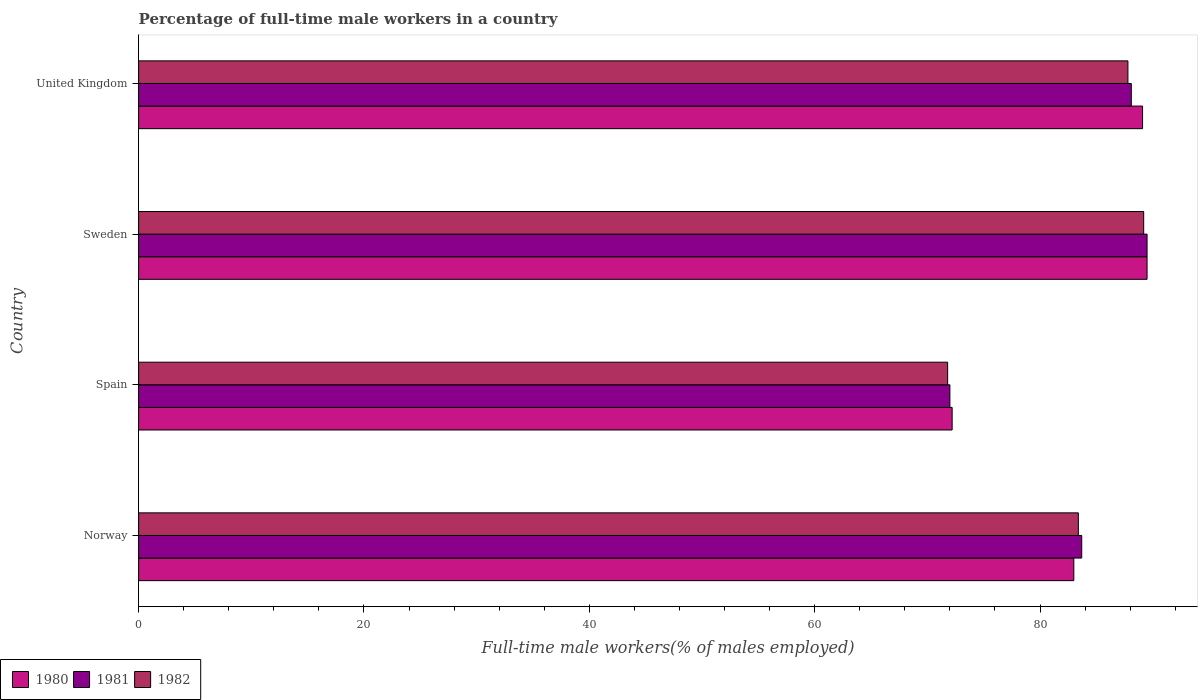How many different coloured bars are there?
Offer a terse response. 3. Are the number of bars per tick equal to the number of legend labels?
Your answer should be very brief. Yes. Are the number of bars on each tick of the Y-axis equal?
Your answer should be very brief. Yes. How many bars are there on the 1st tick from the bottom?
Keep it short and to the point. 3. What is the percentage of full-time male workers in 1982 in Sweden?
Make the answer very short. 89.2. Across all countries, what is the maximum percentage of full-time male workers in 1982?
Keep it short and to the point. 89.2. Across all countries, what is the minimum percentage of full-time male workers in 1981?
Your response must be concise. 72. In which country was the percentage of full-time male workers in 1980 maximum?
Keep it short and to the point. Sweden. In which country was the percentage of full-time male workers in 1981 minimum?
Offer a very short reply. Spain. What is the total percentage of full-time male workers in 1982 in the graph?
Keep it short and to the point. 332.2. What is the difference between the percentage of full-time male workers in 1980 in Spain and that in Sweden?
Offer a terse response. -17.3. What is the difference between the percentage of full-time male workers in 1982 in United Kingdom and the percentage of full-time male workers in 1981 in Sweden?
Offer a very short reply. -1.7. What is the average percentage of full-time male workers in 1981 per country?
Keep it short and to the point. 83.32. What is the difference between the percentage of full-time male workers in 1981 and percentage of full-time male workers in 1982 in Sweden?
Give a very brief answer. 0.3. In how many countries, is the percentage of full-time male workers in 1980 greater than 40 %?
Provide a short and direct response. 4. What is the ratio of the percentage of full-time male workers in 1982 in Spain to that in United Kingdom?
Offer a very short reply. 0.82. Is the difference between the percentage of full-time male workers in 1981 in Spain and United Kingdom greater than the difference between the percentage of full-time male workers in 1982 in Spain and United Kingdom?
Give a very brief answer. No. What is the difference between the highest and the second highest percentage of full-time male workers in 1982?
Make the answer very short. 1.4. What is the difference between the highest and the lowest percentage of full-time male workers in 1981?
Your answer should be very brief. 17.5. Is the sum of the percentage of full-time male workers in 1981 in Spain and Sweden greater than the maximum percentage of full-time male workers in 1982 across all countries?
Provide a short and direct response. Yes. How many countries are there in the graph?
Offer a very short reply. 4. Are the values on the major ticks of X-axis written in scientific E-notation?
Keep it short and to the point. No. Does the graph contain any zero values?
Your response must be concise. No. What is the title of the graph?
Provide a short and direct response. Percentage of full-time male workers in a country. What is the label or title of the X-axis?
Ensure brevity in your answer.  Full-time male workers(% of males employed). What is the label or title of the Y-axis?
Provide a short and direct response. Country. What is the Full-time male workers(% of males employed) of 1981 in Norway?
Make the answer very short. 83.7. What is the Full-time male workers(% of males employed) of 1982 in Norway?
Keep it short and to the point. 83.4. What is the Full-time male workers(% of males employed) in 1980 in Spain?
Make the answer very short. 72.2. What is the Full-time male workers(% of males employed) of 1981 in Spain?
Your answer should be very brief. 72. What is the Full-time male workers(% of males employed) in 1982 in Spain?
Your answer should be very brief. 71.8. What is the Full-time male workers(% of males employed) of 1980 in Sweden?
Offer a terse response. 89.5. What is the Full-time male workers(% of males employed) of 1981 in Sweden?
Your response must be concise. 89.5. What is the Full-time male workers(% of males employed) of 1982 in Sweden?
Ensure brevity in your answer.  89.2. What is the Full-time male workers(% of males employed) in 1980 in United Kingdom?
Offer a very short reply. 89.1. What is the Full-time male workers(% of males employed) of 1981 in United Kingdom?
Offer a very short reply. 88.1. What is the Full-time male workers(% of males employed) in 1982 in United Kingdom?
Provide a short and direct response. 87.8. Across all countries, what is the maximum Full-time male workers(% of males employed) in 1980?
Provide a short and direct response. 89.5. Across all countries, what is the maximum Full-time male workers(% of males employed) of 1981?
Offer a terse response. 89.5. Across all countries, what is the maximum Full-time male workers(% of males employed) in 1982?
Provide a succinct answer. 89.2. Across all countries, what is the minimum Full-time male workers(% of males employed) in 1980?
Your answer should be compact. 72.2. Across all countries, what is the minimum Full-time male workers(% of males employed) of 1981?
Your response must be concise. 72. Across all countries, what is the minimum Full-time male workers(% of males employed) in 1982?
Your answer should be compact. 71.8. What is the total Full-time male workers(% of males employed) in 1980 in the graph?
Your response must be concise. 333.8. What is the total Full-time male workers(% of males employed) in 1981 in the graph?
Your response must be concise. 333.3. What is the total Full-time male workers(% of males employed) in 1982 in the graph?
Your answer should be compact. 332.2. What is the difference between the Full-time male workers(% of males employed) of 1980 in Norway and that in Spain?
Provide a short and direct response. 10.8. What is the difference between the Full-time male workers(% of males employed) of 1981 in Norway and that in Spain?
Offer a terse response. 11.7. What is the difference between the Full-time male workers(% of males employed) in 1981 in Norway and that in Sweden?
Offer a very short reply. -5.8. What is the difference between the Full-time male workers(% of males employed) of 1982 in Norway and that in Sweden?
Your answer should be very brief. -5.8. What is the difference between the Full-time male workers(% of males employed) of 1980 in Norway and that in United Kingdom?
Your answer should be very brief. -6.1. What is the difference between the Full-time male workers(% of males employed) of 1980 in Spain and that in Sweden?
Provide a succinct answer. -17.3. What is the difference between the Full-time male workers(% of males employed) of 1981 in Spain and that in Sweden?
Keep it short and to the point. -17.5. What is the difference between the Full-time male workers(% of males employed) of 1982 in Spain and that in Sweden?
Your response must be concise. -17.4. What is the difference between the Full-time male workers(% of males employed) of 1980 in Spain and that in United Kingdom?
Make the answer very short. -16.9. What is the difference between the Full-time male workers(% of males employed) of 1981 in Spain and that in United Kingdom?
Make the answer very short. -16.1. What is the difference between the Full-time male workers(% of males employed) of 1980 in Sweden and that in United Kingdom?
Give a very brief answer. 0.4. What is the difference between the Full-time male workers(% of males employed) in 1980 in Norway and the Full-time male workers(% of males employed) in 1981 in Spain?
Offer a terse response. 11. What is the difference between the Full-time male workers(% of males employed) of 1980 in Norway and the Full-time male workers(% of males employed) of 1982 in Spain?
Offer a very short reply. 11.2. What is the difference between the Full-time male workers(% of males employed) in 1980 in Norway and the Full-time male workers(% of males employed) in 1981 in Sweden?
Give a very brief answer. -6.5. What is the difference between the Full-time male workers(% of males employed) in 1981 in Norway and the Full-time male workers(% of males employed) in 1982 in Sweden?
Provide a short and direct response. -5.5. What is the difference between the Full-time male workers(% of males employed) of 1981 in Norway and the Full-time male workers(% of males employed) of 1982 in United Kingdom?
Ensure brevity in your answer.  -4.1. What is the difference between the Full-time male workers(% of males employed) in 1980 in Spain and the Full-time male workers(% of males employed) in 1981 in Sweden?
Provide a succinct answer. -17.3. What is the difference between the Full-time male workers(% of males employed) of 1981 in Spain and the Full-time male workers(% of males employed) of 1982 in Sweden?
Make the answer very short. -17.2. What is the difference between the Full-time male workers(% of males employed) of 1980 in Spain and the Full-time male workers(% of males employed) of 1981 in United Kingdom?
Your answer should be compact. -15.9. What is the difference between the Full-time male workers(% of males employed) in 1980 in Spain and the Full-time male workers(% of males employed) in 1982 in United Kingdom?
Your answer should be very brief. -15.6. What is the difference between the Full-time male workers(% of males employed) of 1981 in Spain and the Full-time male workers(% of males employed) of 1982 in United Kingdom?
Keep it short and to the point. -15.8. What is the difference between the Full-time male workers(% of males employed) in 1980 in Sweden and the Full-time male workers(% of males employed) in 1981 in United Kingdom?
Your answer should be very brief. 1.4. What is the average Full-time male workers(% of males employed) in 1980 per country?
Provide a succinct answer. 83.45. What is the average Full-time male workers(% of males employed) of 1981 per country?
Ensure brevity in your answer.  83.33. What is the average Full-time male workers(% of males employed) of 1982 per country?
Make the answer very short. 83.05. What is the difference between the Full-time male workers(% of males employed) of 1980 and Full-time male workers(% of males employed) of 1981 in Norway?
Make the answer very short. -0.7. What is the difference between the Full-time male workers(% of males employed) of 1980 and Full-time male workers(% of males employed) of 1981 in Spain?
Ensure brevity in your answer.  0.2. What is the difference between the Full-time male workers(% of males employed) in 1980 and Full-time male workers(% of males employed) in 1982 in Spain?
Your response must be concise. 0.4. What is the difference between the Full-time male workers(% of males employed) in 1981 and Full-time male workers(% of males employed) in 1982 in Spain?
Offer a very short reply. 0.2. What is the difference between the Full-time male workers(% of males employed) of 1980 and Full-time male workers(% of males employed) of 1981 in United Kingdom?
Make the answer very short. 1. What is the difference between the Full-time male workers(% of males employed) in 1981 and Full-time male workers(% of males employed) in 1982 in United Kingdom?
Provide a succinct answer. 0.3. What is the ratio of the Full-time male workers(% of males employed) in 1980 in Norway to that in Spain?
Provide a succinct answer. 1.15. What is the ratio of the Full-time male workers(% of males employed) of 1981 in Norway to that in Spain?
Provide a succinct answer. 1.16. What is the ratio of the Full-time male workers(% of males employed) of 1982 in Norway to that in Spain?
Offer a terse response. 1.16. What is the ratio of the Full-time male workers(% of males employed) of 1980 in Norway to that in Sweden?
Keep it short and to the point. 0.93. What is the ratio of the Full-time male workers(% of males employed) in 1981 in Norway to that in Sweden?
Offer a very short reply. 0.94. What is the ratio of the Full-time male workers(% of males employed) of 1982 in Norway to that in Sweden?
Your response must be concise. 0.94. What is the ratio of the Full-time male workers(% of males employed) of 1980 in Norway to that in United Kingdom?
Keep it short and to the point. 0.93. What is the ratio of the Full-time male workers(% of males employed) in 1981 in Norway to that in United Kingdom?
Give a very brief answer. 0.95. What is the ratio of the Full-time male workers(% of males employed) in 1982 in Norway to that in United Kingdom?
Make the answer very short. 0.95. What is the ratio of the Full-time male workers(% of males employed) of 1980 in Spain to that in Sweden?
Provide a succinct answer. 0.81. What is the ratio of the Full-time male workers(% of males employed) of 1981 in Spain to that in Sweden?
Your answer should be compact. 0.8. What is the ratio of the Full-time male workers(% of males employed) in 1982 in Spain to that in Sweden?
Offer a very short reply. 0.8. What is the ratio of the Full-time male workers(% of males employed) of 1980 in Spain to that in United Kingdom?
Your response must be concise. 0.81. What is the ratio of the Full-time male workers(% of males employed) of 1981 in Spain to that in United Kingdom?
Offer a very short reply. 0.82. What is the ratio of the Full-time male workers(% of males employed) in 1982 in Spain to that in United Kingdom?
Ensure brevity in your answer.  0.82. What is the ratio of the Full-time male workers(% of males employed) in 1981 in Sweden to that in United Kingdom?
Keep it short and to the point. 1.02. What is the ratio of the Full-time male workers(% of males employed) of 1982 in Sweden to that in United Kingdom?
Offer a terse response. 1.02. What is the difference between the highest and the second highest Full-time male workers(% of males employed) in 1980?
Your answer should be very brief. 0.4. What is the difference between the highest and the second highest Full-time male workers(% of males employed) of 1982?
Keep it short and to the point. 1.4. 